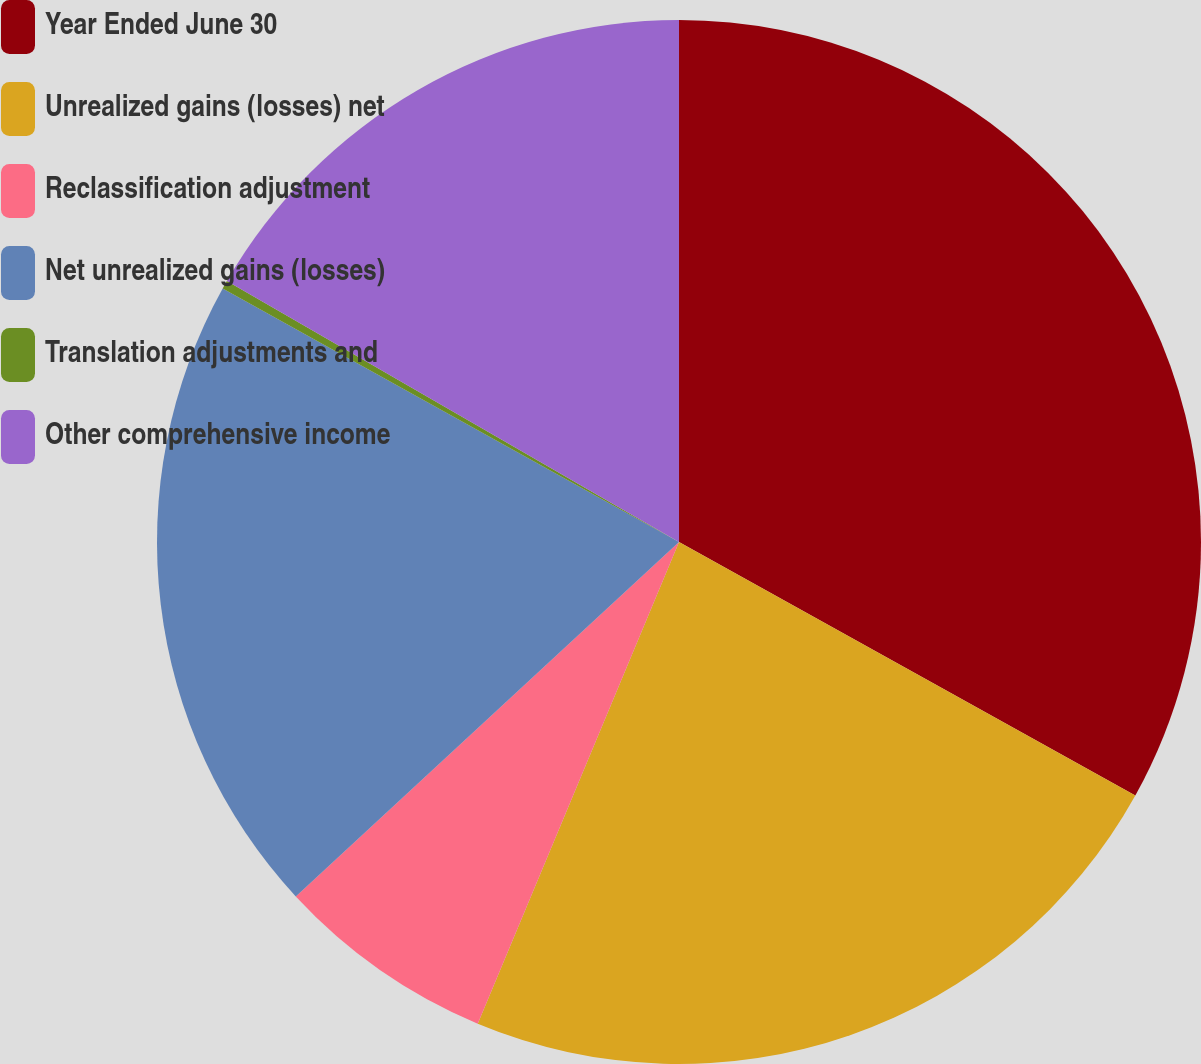<chart> <loc_0><loc_0><loc_500><loc_500><pie_chart><fcel>Year Ended June 30<fcel>Unrealized gains (losses) net<fcel>Reclassification adjustment<fcel>Net unrealized gains (losses)<fcel>Translation adjustments and<fcel>Other comprehensive income<nl><fcel>33.07%<fcel>23.23%<fcel>6.82%<fcel>19.95%<fcel>0.26%<fcel>16.67%<nl></chart> 